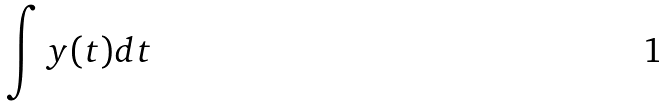<formula> <loc_0><loc_0><loc_500><loc_500>\int y ( t ) d t</formula> 